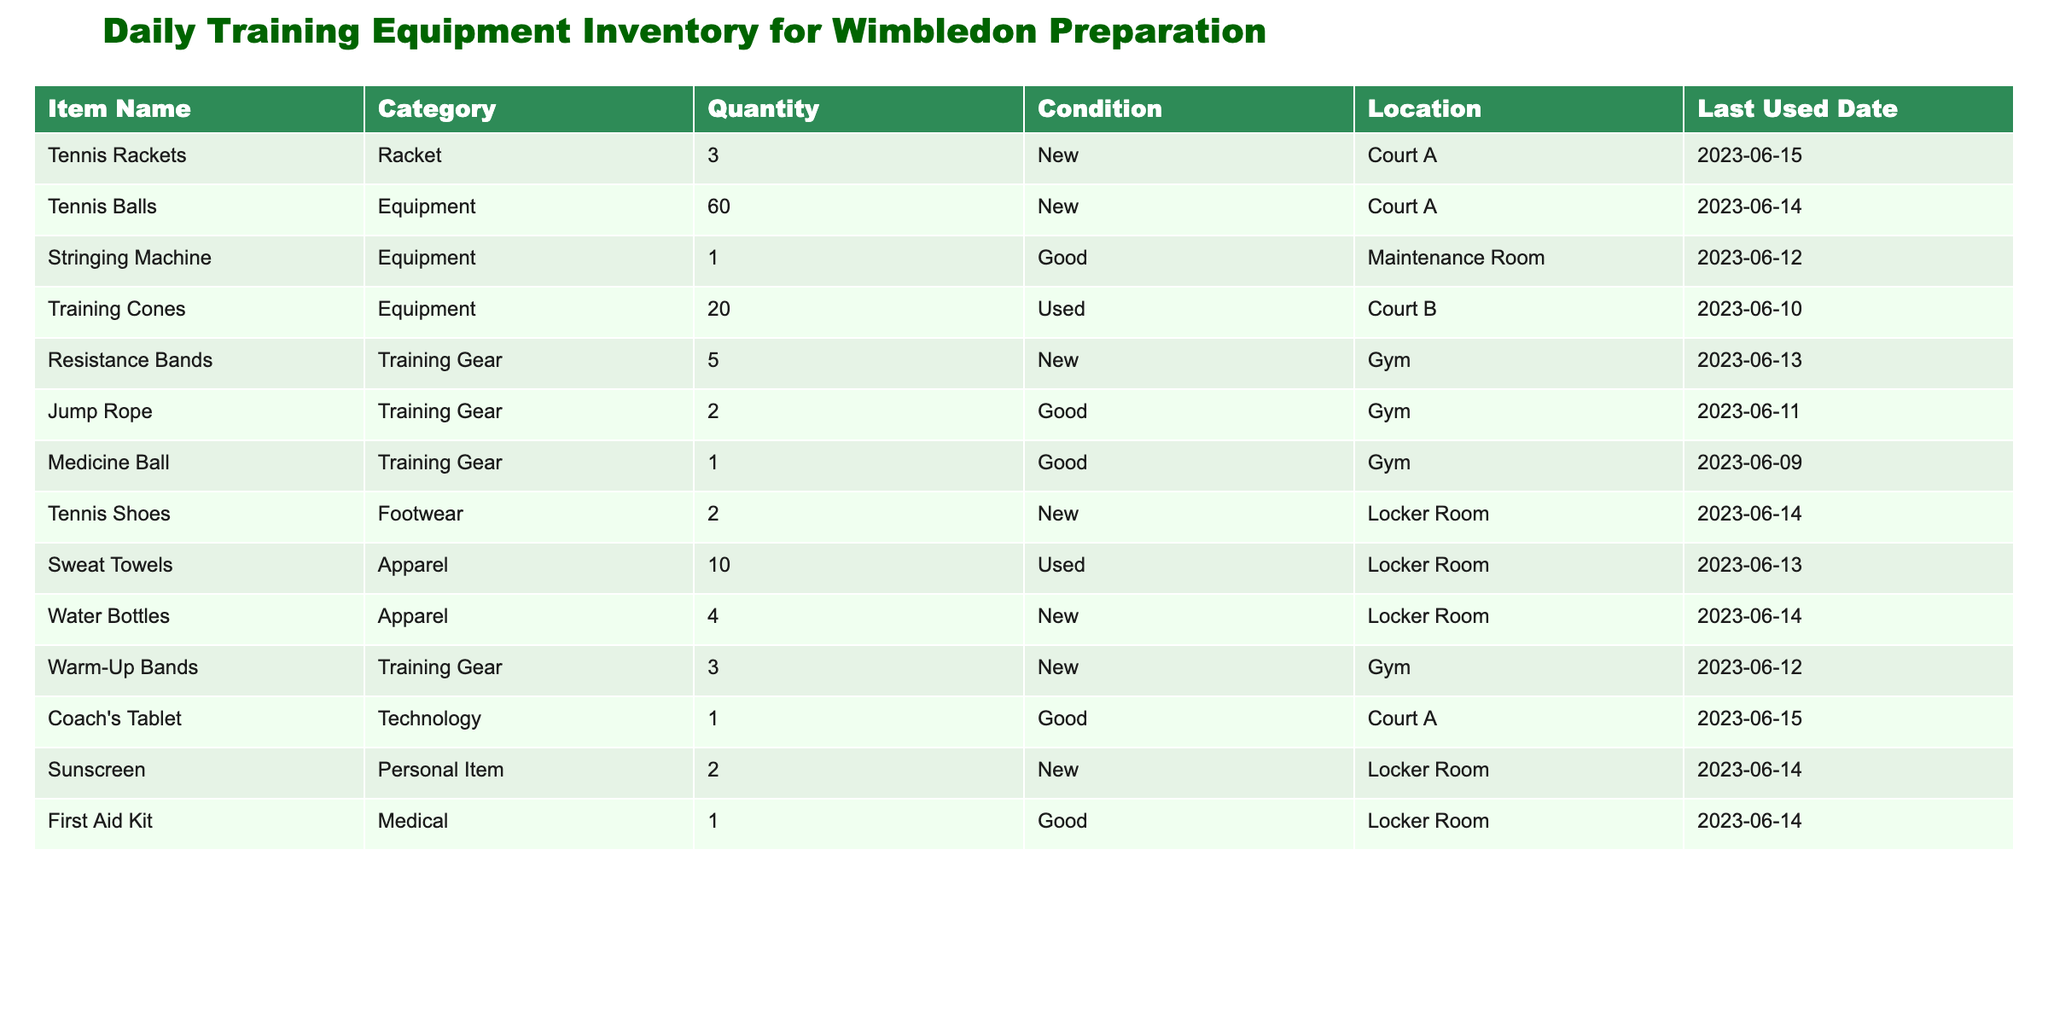What is the total quantity of tennis balls available? The table lists the tennis balls under the 'Quantity' column, showing a total of 60.
Answer: 60 How many items in the inventory are categorized as 'Training Gear'? By reviewing the 'Category' column, I can identify that there are 5 items classified as 'Training Gear': Resistance Bands, Jump Rope, Medicine Ball, Warm-Up Bands, and Tennis Rackets.
Answer: 5 What is the total number of items in the 'Locker Room'? The items located in the 'Locker Room' are Tennis Shoes, Sweat Towels, Water Bottles, Sunscreen, and First Aid Kit. Adding these gives a count of 5 items in total.
Answer: 5 Is the Stringing Machine in 'Good' condition? The 'Condition' column for the Stringing Machine states 'Good', which confirms that it is indeed in good condition.
Answer: Yes Which equipment was last used in the Gym, and on what date? I can look at the 'Last Used Date' column for items listed under 'Gym'. The last recorded equipment is the Resistance Bands, which were last used on 2023-06-13.
Answer: Resistance Bands, 2023-06-13 What is the average quantity of 'New' condition items in the inventory? Counting the items labeled as 'New' gives us 8 items: Tennis Rackets (3), Tennis Balls (60), Resistance Bands (5), Tennis Shoes (2), Water Bottles (4), and Sunscreen (2). Adding these gives a total quantity of 76. Dividing by 8 yields an average of 9.5.
Answer: 9.5 Are there more used items in the inventory than new items? There are 3 items listed as 'Used' (Training Cones, Sweat Towels), while there are 8 items in 'New' condition. Since 3 is less than 8, it confirms there are more new items.
Answer: No What is the total quantity of equipment available on Court A? Items found at Court A are Tennis Rackets, Tennis Balls, and Coach's Tablet. Adding their quantities gives: 3 (Rackets) + 60 (Balls) + 1 (Tablet) = 64.
Answer: 64 What type of footwear is listed, and how many pairs are available? The table identifies 'Tennis Shoes' under the 'Footwear' category, showing a total of 2 pairs available.
Answer: Tennis Shoes, 2 